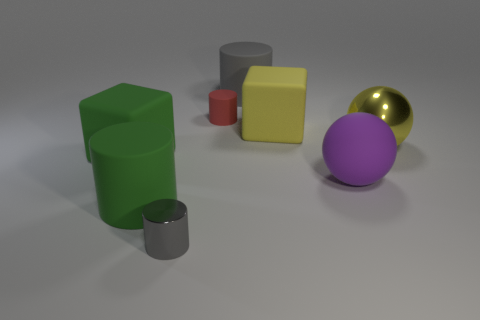Subtract all rubber cylinders. How many cylinders are left? 1 Add 1 metal things. How many objects exist? 9 Subtract all green cylinders. How many cylinders are left? 3 Subtract all blue spheres. How many gray cylinders are left? 2 Subtract all spheres. How many objects are left? 6 Subtract 1 cylinders. How many cylinders are left? 3 Subtract 0 red blocks. How many objects are left? 8 Subtract all yellow blocks. Subtract all brown balls. How many blocks are left? 1 Subtract all large rubber things. Subtract all brown matte cylinders. How many objects are left? 3 Add 7 red rubber objects. How many red rubber objects are left? 8 